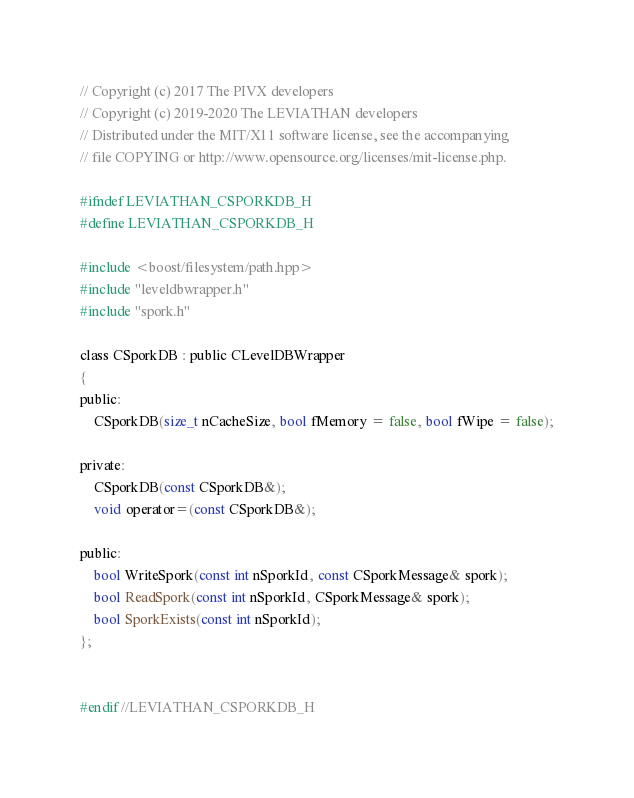Convert code to text. <code><loc_0><loc_0><loc_500><loc_500><_C_>// Copyright (c) 2017 The PIVX developers
// Copyright (c) 2019-2020 The LEVIATHAN developers
// Distributed under the MIT/X11 software license, see the accompanying
// file COPYING or http://www.opensource.org/licenses/mit-license.php.

#ifndef LEVIATHAN_CSPORKDB_H
#define LEVIATHAN_CSPORKDB_H

#include <boost/filesystem/path.hpp>
#include "leveldbwrapper.h"
#include "spork.h"

class CSporkDB : public CLevelDBWrapper
{
public:
    CSporkDB(size_t nCacheSize, bool fMemory = false, bool fWipe = false);

private:
    CSporkDB(const CSporkDB&);
    void operator=(const CSporkDB&);

public:
    bool WriteSpork(const int nSporkId, const CSporkMessage& spork);
    bool ReadSpork(const int nSporkId, CSporkMessage& spork);
    bool SporkExists(const int nSporkId);
};


#endif //LEVIATHAN_CSPORKDB_H
</code> 